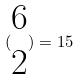<formula> <loc_0><loc_0><loc_500><loc_500>( \begin{matrix} 6 \\ 2 \end{matrix} ) = 1 5</formula> 